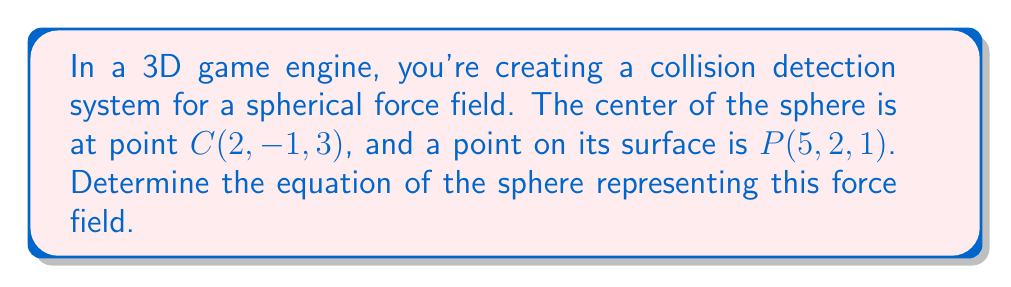What is the answer to this math problem? Let's approach this step-by-step:

1) The general equation of a sphere is:

   $$(x - h)^2 + (y - k)^2 + (z - l)^2 = r^2$$

   where $(h, k, l)$ is the center and $r$ is the radius.

2) We're given the center $C(2, -1, 3)$, so $h = 2$, $k = -1$, and $l = 3$.

3) To find the radius, we need to calculate the distance between the center $C(2, -1, 3)$ and the point on the surface $P(5, 2, 1)$.

4) We can use the distance formula in 3D space:

   $$r = \sqrt{(x_2 - x_1)^2 + (y_2 - y_1)^2 + (z_2 - z_1)^2}$$

5) Plugging in our values:

   $$r = \sqrt{(5 - 2)^2 + (2 - (-1))^2 + (1 - 3)^2}$$

6) Simplify:

   $$r = \sqrt{3^2 + 3^2 + (-2)^2} = \sqrt{9 + 9 + 4} = \sqrt{22}$$

7) Now we have all the components to write our equation. Substituting into the general form:

   $$(x - 2)^2 + (y - (-1))^2 + (z - 3)^2 = (\sqrt{22})^2$$

8) Simplify:

   $$(x - 2)^2 + (y + 1)^2 + (z - 3)^2 = 22$$

This is the equation of our sphere.
Answer: $(x - 2)^2 + (y + 1)^2 + (z - 3)^2 = 22$ 